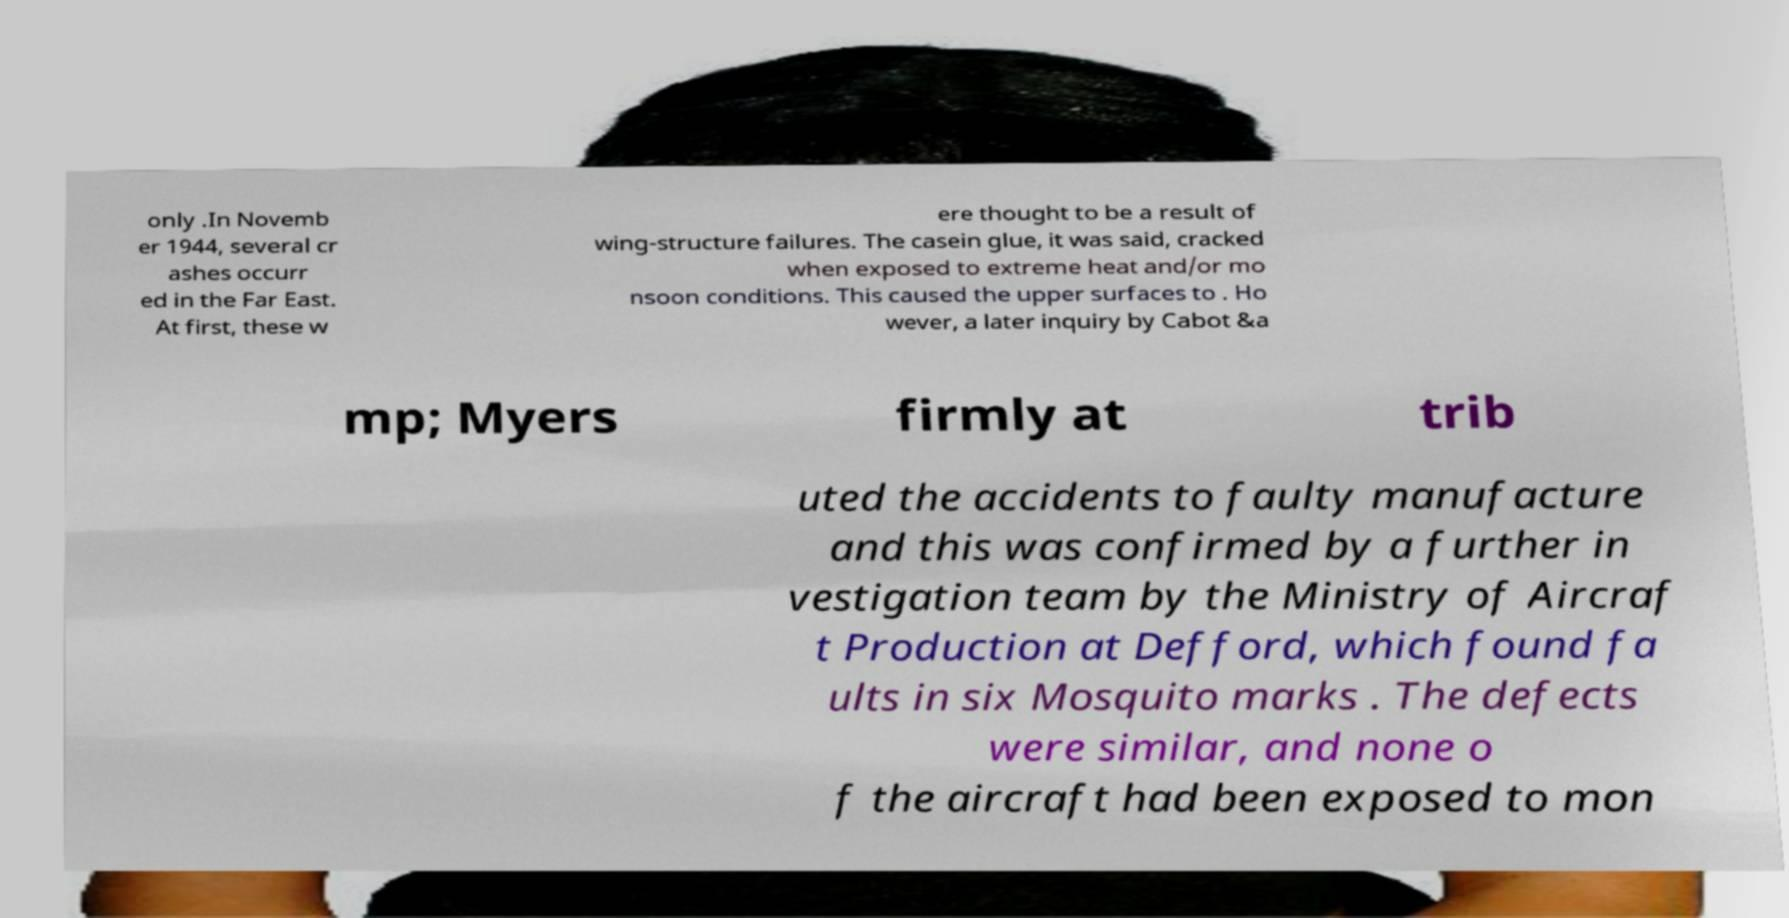Can you accurately transcribe the text from the provided image for me? only .In Novemb er 1944, several cr ashes occurr ed in the Far East. At first, these w ere thought to be a result of wing-structure failures. The casein glue, it was said, cracked when exposed to extreme heat and/or mo nsoon conditions. This caused the upper surfaces to . Ho wever, a later inquiry by Cabot &a mp; Myers firmly at trib uted the accidents to faulty manufacture and this was confirmed by a further in vestigation team by the Ministry of Aircraf t Production at Defford, which found fa ults in six Mosquito marks . The defects were similar, and none o f the aircraft had been exposed to mon 